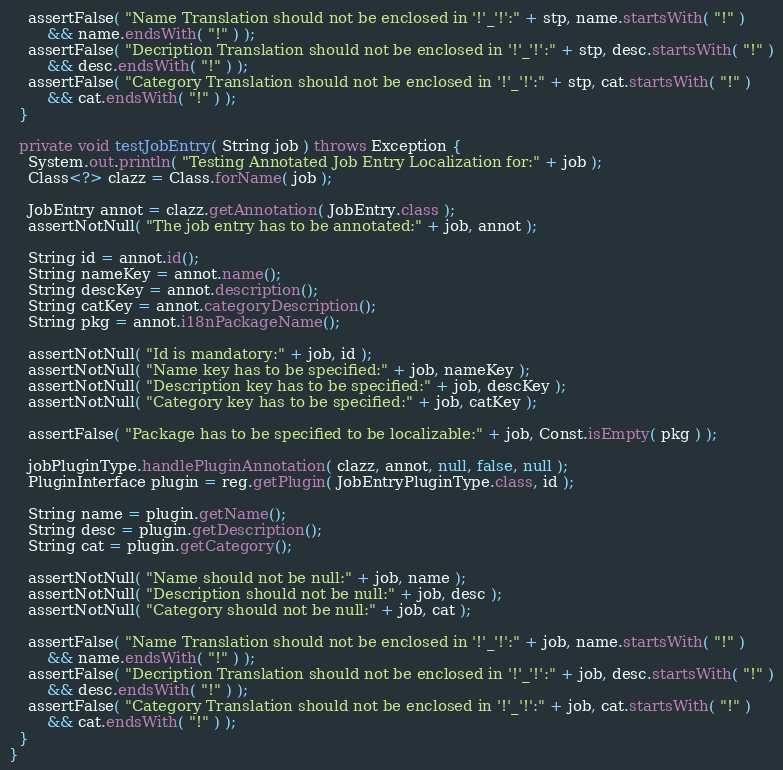<code> <loc_0><loc_0><loc_500><loc_500><_Java_>
    assertFalse( "Name Translation should not be enclosed in '!'_'!':" + stp, name.startsWith( "!" )
        && name.endsWith( "!" ) );
    assertFalse( "Decription Translation should not be enclosed in '!'_'!':" + stp, desc.startsWith( "!" )
        && desc.endsWith( "!" ) );
    assertFalse( "Category Translation should not be enclosed in '!'_'!':" + stp, cat.startsWith( "!" )
        && cat.endsWith( "!" ) );
  }

  private void testJobEntry( String job ) throws Exception {
    System.out.println( "Testing Annotated Job Entry Localization for:" + job );
    Class<?> clazz = Class.forName( job );

    JobEntry annot = clazz.getAnnotation( JobEntry.class );
    assertNotNull( "The job entry has to be annotated:" + job, annot );

    String id = annot.id();
    String nameKey = annot.name();
    String descKey = annot.description();
    String catKey = annot.categoryDescription();
    String pkg = annot.i18nPackageName();

    assertNotNull( "Id is mandatory:" + job, id );
    assertNotNull( "Name key has to be specified:" + job, nameKey );
    assertNotNull( "Description key has to be specified:" + job, descKey );
    assertNotNull( "Category key has to be specified:" + job, catKey );

    assertFalse( "Package has to be specified to be localizable:" + job, Const.isEmpty( pkg ) );

    jobPluginType.handlePluginAnnotation( clazz, annot, null, false, null );
    PluginInterface plugin = reg.getPlugin( JobEntryPluginType.class, id );

    String name = plugin.getName();
    String desc = plugin.getDescription();
    String cat = plugin.getCategory();

    assertNotNull( "Name should not be null:" + job, name );
    assertNotNull( "Description should not be null:" + job, desc );
    assertNotNull( "Category should not be null:" + job, cat );

    assertFalse( "Name Translation should not be enclosed in '!'_'!':" + job, name.startsWith( "!" )
        && name.endsWith( "!" ) );
    assertFalse( "Decription Translation should not be enclosed in '!'_'!':" + job, desc.startsWith( "!" )
        && desc.endsWith( "!" ) );
    assertFalse( "Category Translation should not be enclosed in '!'_'!':" + job, cat.startsWith( "!" )
        && cat.endsWith( "!" ) );
  }
}
</code> 